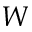<formula> <loc_0><loc_0><loc_500><loc_500>W</formula> 